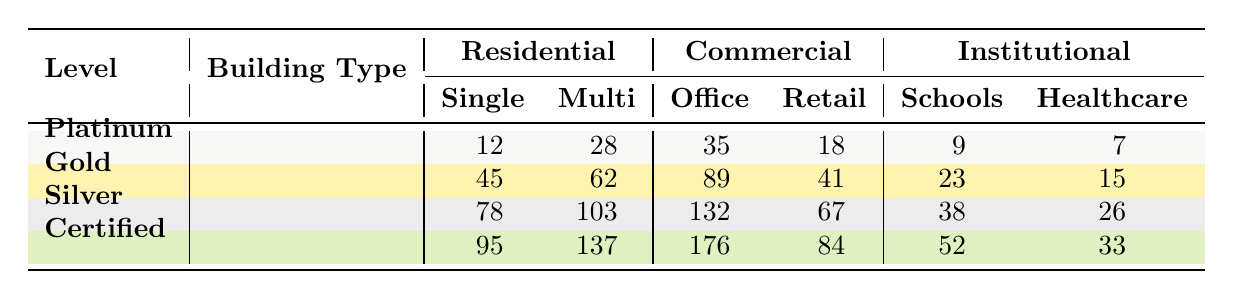What is the total number of Platinum-certified single-family homes? In the table, the number of Platinum-certified single-family homes is listed under the Residential category for the Platinum level, which is 12.
Answer: 12 What is the total number of Gold-certified office buildings? The table specifies that there are 89 Gold-certified office buildings under the Commercial category.
Answer: 89 How many more Silver-certified multi-family buildings are there compared to Platinum-certified ones? For Silver certification, there are 103 multi-family buildings, and for Platinum certification, there are 28 multi-family buildings. Calculating the difference gives 103 - 28 = 75.
Answer: 75 How many total Certified buildings are there across all categories? To find the total Certified buildings, we sum all values: 95 (Single-family) + 137 (Multi-family) + 176 (Office) + 84 (Retail) + 52 (Schools) + 33 (Healthcare) = 677.
Answer: 677 Which building type has the highest number of Gold certifications? The table shows that Gold-certified office buildings have the highest number, totaling 89, compared to other Gold-certified categories.
Answer: Office buildings Are there more certified multi-family buildings than certified single-family homes? Yes, there are 137 certified multi-family buildings and 95 certified single-family homes. Since 137 is greater than 95, the answer is yes.
Answer: Yes What is the difference between the number of Silver-certified retail spaces and Platinum-certified retail spaces? For Silver, there are 67 retail spaces, and for Platinum, there are 18 retail spaces. The difference is 67 - 18 = 49.
Answer: 49 What percentage of the total institutional buildings are Platinum-certified schools? There are 9 Platinum-certified schools out of a total of 52 (schools) + 33 (healthcare) = 85 institutional buildings. The percentage is (9 / 85) * 100 ≈ 10.59%.
Answer: Approximately 10.59% Which LEED certification level has the lowest total buildings when combining all categories? By calculating the totals for each level, we find: Platinum (12 + 28 + 35 + 18 + 9 + 7 = 109), Gold (45 + 62 + 89 + 41 + 23 + 15 = 275), Silver (78 + 103 + 132 + 67 + 38 + 26 = 444), and Certified (95 + 137 + 176 + 84 + 52 + 33 = 677). Platinum has the lowest total with 109.
Answer: Platinum How many Healthcare facilities are there in total across all certification levels? The table shows 7 (Platinum) + 15 (Gold) + 26 (Silver) + 33 (Certified) = 81 healthcare facilities in total across all certification levels.
Answer: 81 